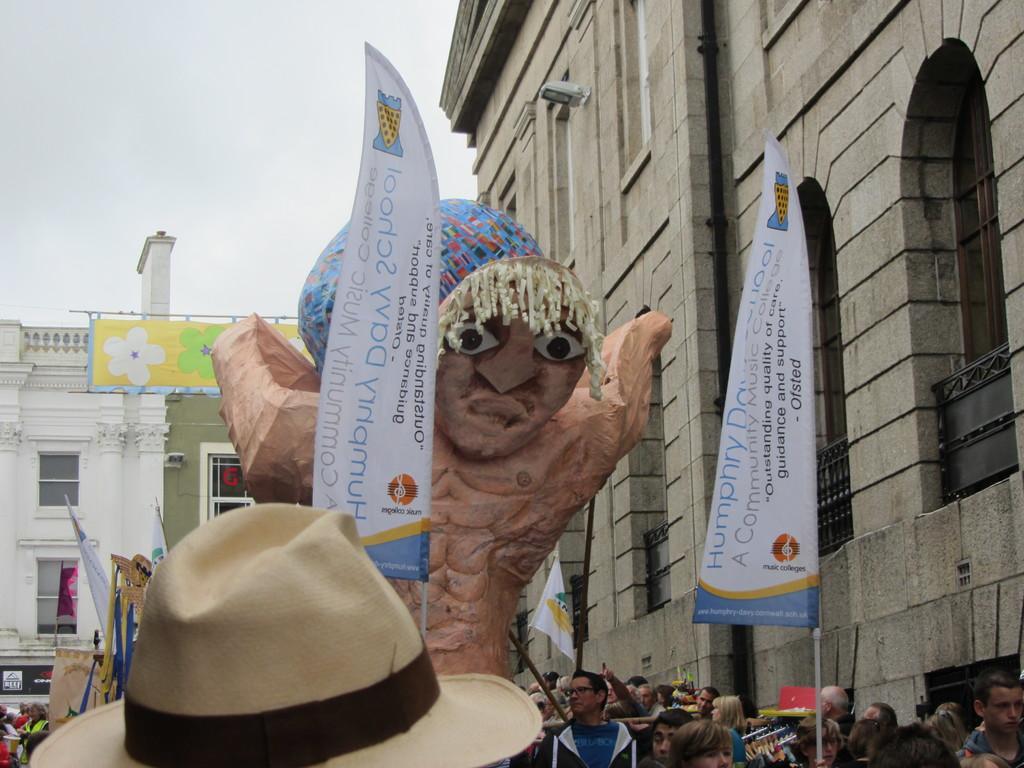How would you summarize this image in a sentence or two? This is an outside view. In the middle of the image there is an object which seems to be a wooden sculpture. At the bottom, I can see a crowd of people. In the bottom left-hand corner there is a cap. Here I can see two flags on which there is some text. In the background there are few buildings. At the top of the image I can see the sky. 